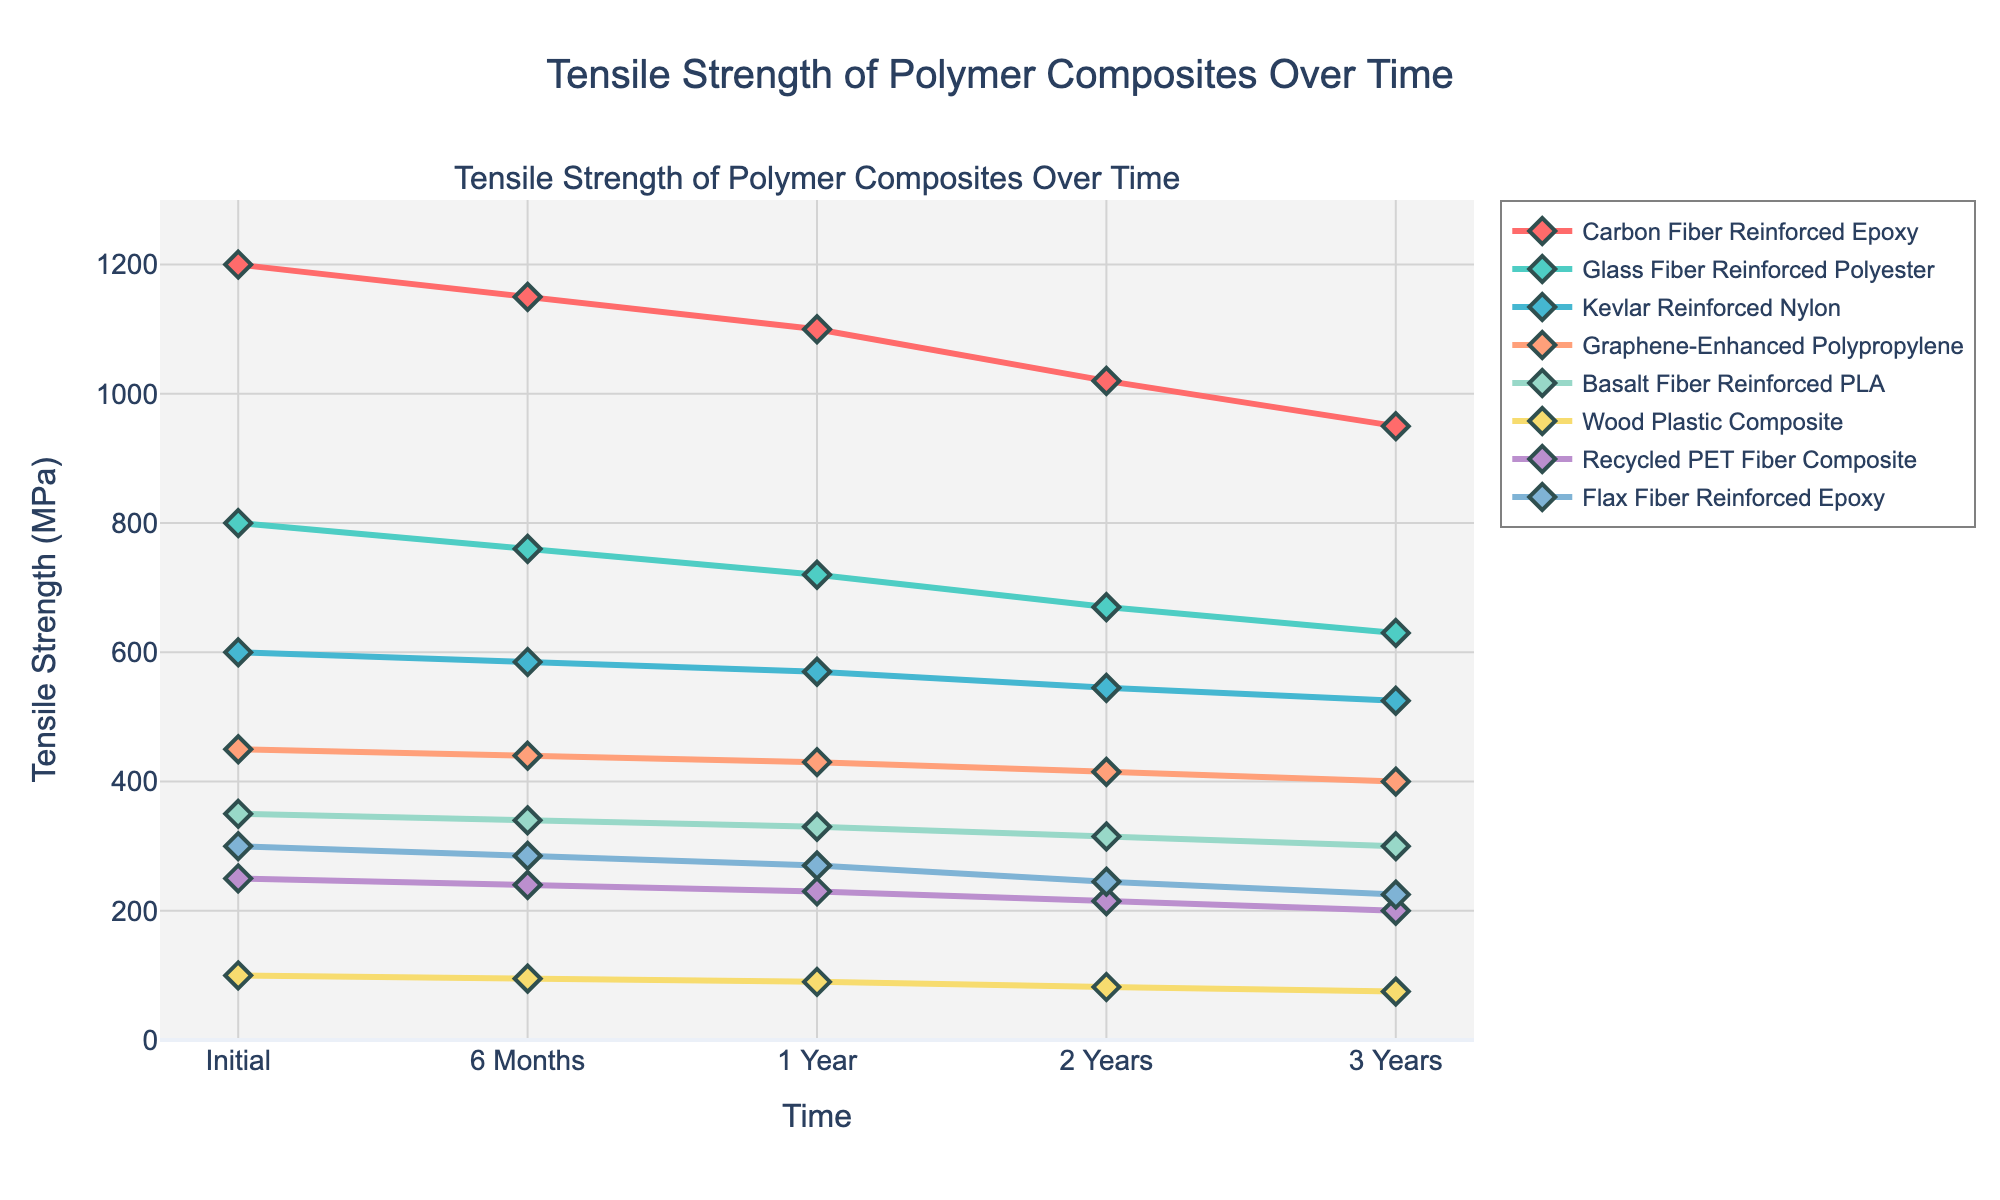Which material maintains the highest tensile strength after 3 years? The figure depicts tensile strength of various materials over time. After 3 years, "Carbon Fiber Reinforced Epoxy" has the highest tensile strength at 950 MPa.
Answer: Carbon Fiber Reinforced Epoxy Which material shows the greatest decrease in tensile strength over 3 years? To determine the greatest decrease, subtract the final tensile strength (after 3 years) from the initial tensile strength for each material and identify the largest difference. Carbon Fiber Reinforced Epoxy decreases from 1200 MPa to 950 MPa, a difference of 250 MPa.
Answer: Carbon Fiber Reinforced Epoxy Which two materials have nearly parallel lines over the 3 years, indicating a similar rate of degradation? By closely observing the slopes of the lines for each material, the lines for "Kevlar Reinforced Nylon" and "Graphene-Enhanced Polypropylene" appear nearly parallel, indicating a similar degradation rate.
Answer: Kevlar Reinforced Nylon and Graphene-Enhanced Polypropylene What is the average tensile strength of Glass Fiber Reinforced Polyester over the observed time periods? Sum the tensile strengths of Glass Fiber Reinforced Polyester at each time period and divide by the number of time points: (800 + 760 + 720 + 670 + 630) / 5 = 3580 / 5.
Answer: 716 MPa Which material has the smallest decrease in tensile strength from the initial measurement to after 6 months? Subtract the initial tensile strength from the 6 months' tensile strength for each material and identify the smallest difference. Kevlar Reinforced Nylon has the smallest decrease (600 - 585 = 15 MPa).
Answer: Kevlar Reinforced Nylon At the 1-year mark, which material has the highest tensile strength? Observing tensile strengths at the 1-year mark, "Carbon Fiber Reinforced Epoxy" has the highest tensile strength at 1100 MPa.
Answer: Carbon Fiber Reinforced Epoxy Compare the tensile strength of Flax Fiber Reinforced Epoxy and Basalt Fiber Reinforced PLA after 2 years. Which is higher and by how much? At the 2-year mark, Flax Fiber Reinforced Epoxy has 245 MPa, and Basalt Fiber Reinforced PLA has 315 MPa. The difference is 315 - 245 = 70 MPa, with Basalt Fiber Reinforced PLA being higher.
Answer: Basalt Fiber Reinforced PLA by 70 MPa Which material’s tensile strength falls below 250 MPa first, and when does it happen? Observing the decline in tensile strength, Wood Plastic Composite falls below 250 MPa at the initial measurement (100 MPa).
Answer: Wood Plastic Composite at initial measurement What is the median tensile strength of all materials at the 1-year mark? Arrange the tensile strengths at the 1-year mark (1100, 720, 570, 430, 330, 90, 230, 270) in ascending order: (90, 230, 270, 330, 430, 570, 720, 1100). The median of these 8 values is (330 + 430) / 2.
Answer: 380 MPa Which material has a continuous linear decrease in tensile strength over the entire period? By examining the plot, the decline for "Wood Plastic Composite" appears linear as it decreases smoothly without any sudden changes.
Answer: Wood Plastic Composite 